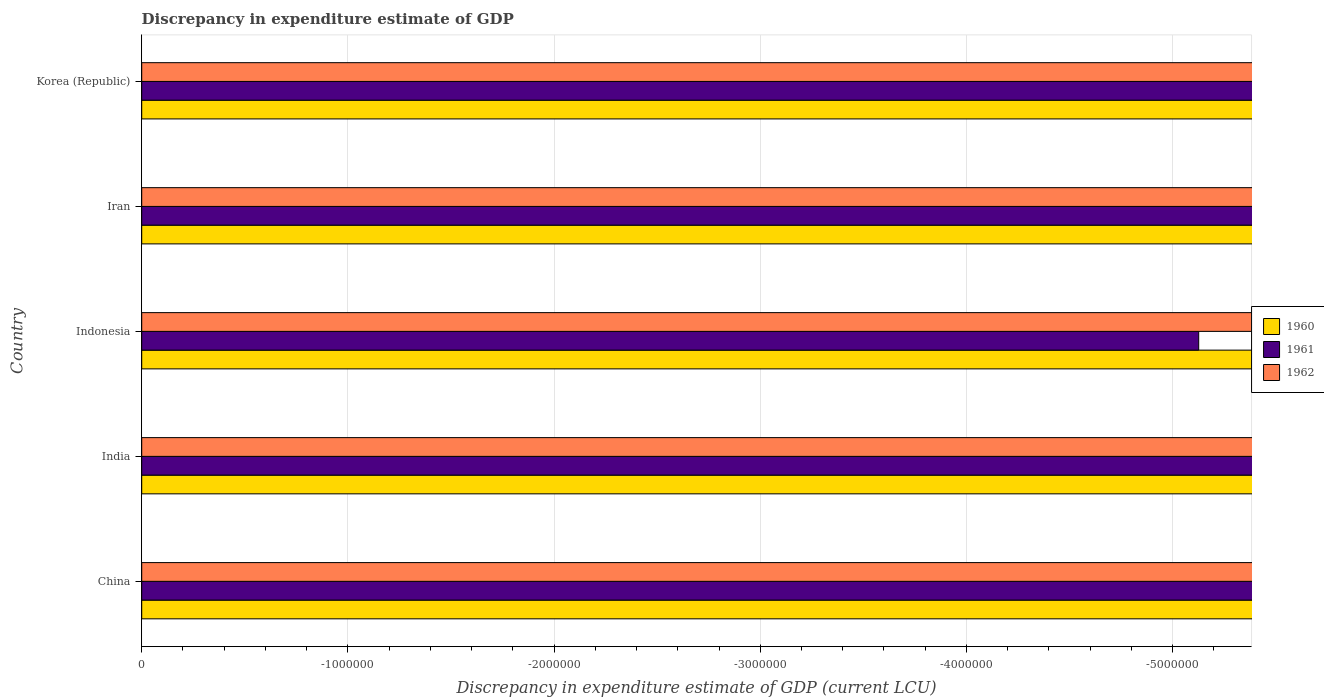How many different coloured bars are there?
Keep it short and to the point. 0. Are the number of bars per tick equal to the number of legend labels?
Your response must be concise. No. Are the number of bars on each tick of the Y-axis equal?
Make the answer very short. Yes. How many bars are there on the 5th tick from the bottom?
Provide a short and direct response. 0. What is the label of the 4th group of bars from the top?
Your answer should be compact. India. What is the total discrepancy in expenditure estimate of GDP in 1961 in the graph?
Offer a very short reply. 0. In how many countries, is the discrepancy in expenditure estimate of GDP in 1962 greater than -1200000 LCU?
Make the answer very short. 0. How many bars are there?
Offer a very short reply. 0. Are all the bars in the graph horizontal?
Make the answer very short. Yes. How many countries are there in the graph?
Give a very brief answer. 5. What is the difference between two consecutive major ticks on the X-axis?
Offer a very short reply. 1.00e+06. Are the values on the major ticks of X-axis written in scientific E-notation?
Your response must be concise. No. Does the graph contain any zero values?
Your response must be concise. Yes. Where does the legend appear in the graph?
Offer a very short reply. Center right. How are the legend labels stacked?
Keep it short and to the point. Vertical. What is the title of the graph?
Give a very brief answer. Discrepancy in expenditure estimate of GDP. What is the label or title of the X-axis?
Offer a terse response. Discrepancy in expenditure estimate of GDP (current LCU). What is the label or title of the Y-axis?
Provide a succinct answer. Country. What is the Discrepancy in expenditure estimate of GDP (current LCU) in 1960 in China?
Offer a terse response. 0. What is the Discrepancy in expenditure estimate of GDP (current LCU) in 1960 in India?
Keep it short and to the point. 0. What is the Discrepancy in expenditure estimate of GDP (current LCU) in 1962 in India?
Your response must be concise. 0. What is the Discrepancy in expenditure estimate of GDP (current LCU) in 1961 in Indonesia?
Your answer should be compact. 0. What is the Discrepancy in expenditure estimate of GDP (current LCU) of 1962 in Iran?
Offer a terse response. 0. What is the Discrepancy in expenditure estimate of GDP (current LCU) in 1962 in Korea (Republic)?
Provide a succinct answer. 0. What is the total Discrepancy in expenditure estimate of GDP (current LCU) in 1960 in the graph?
Give a very brief answer. 0. What is the average Discrepancy in expenditure estimate of GDP (current LCU) in 1960 per country?
Keep it short and to the point. 0. What is the average Discrepancy in expenditure estimate of GDP (current LCU) of 1961 per country?
Provide a succinct answer. 0. What is the average Discrepancy in expenditure estimate of GDP (current LCU) in 1962 per country?
Provide a short and direct response. 0. 